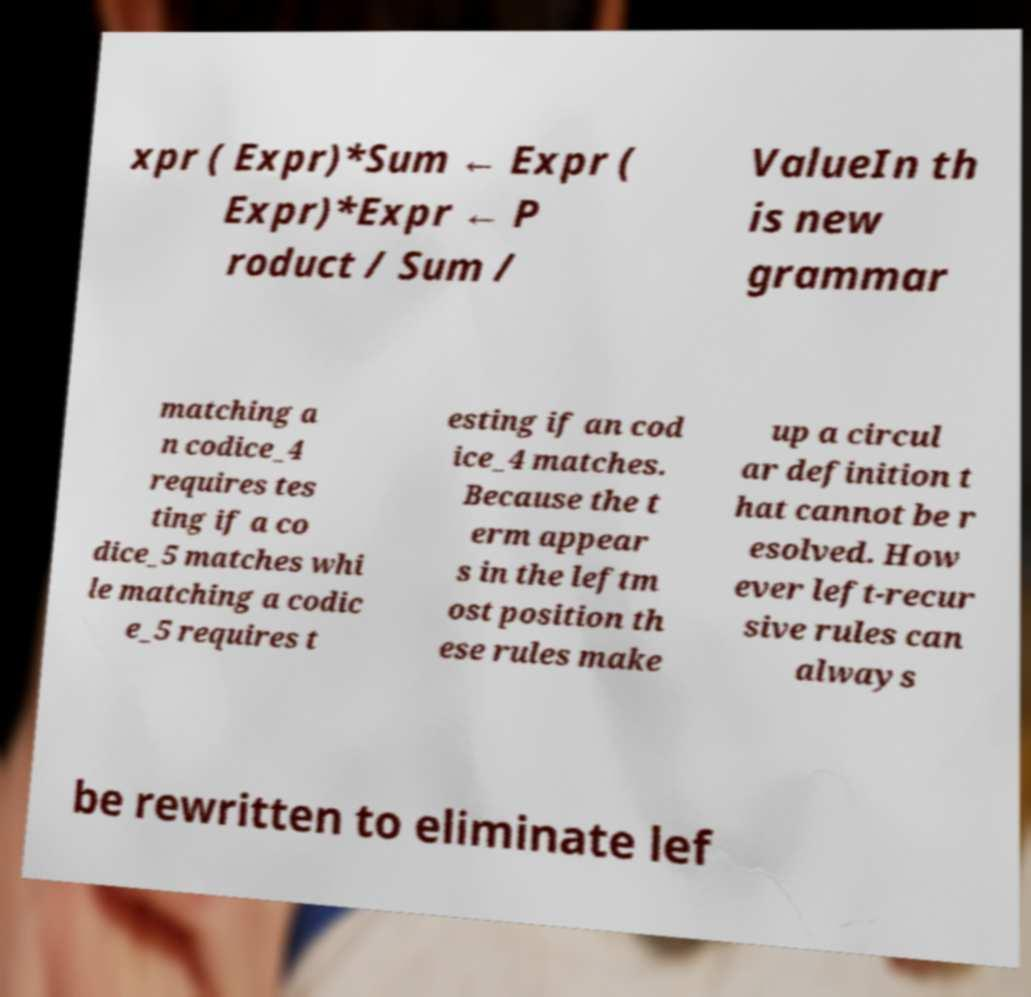Please identify and transcribe the text found in this image. xpr ( Expr)*Sum ← Expr ( Expr)*Expr ← P roduct / Sum / ValueIn th is new grammar matching a n codice_4 requires tes ting if a co dice_5 matches whi le matching a codic e_5 requires t esting if an cod ice_4 matches. Because the t erm appear s in the leftm ost position th ese rules make up a circul ar definition t hat cannot be r esolved. How ever left-recur sive rules can always be rewritten to eliminate lef 